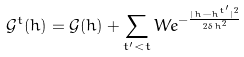Convert formula to latex. <formula><loc_0><loc_0><loc_500><loc_500>\mathcal { G } ^ { t } ( h ) = \mathcal { G } ( h ) + \sum _ { t ^ { \prime } < t } W e ^ { - \frac { | h - h ^ { t ^ { \prime } } | ^ { 2 } } { 2 \delta h ^ { 2 } } }</formula> 